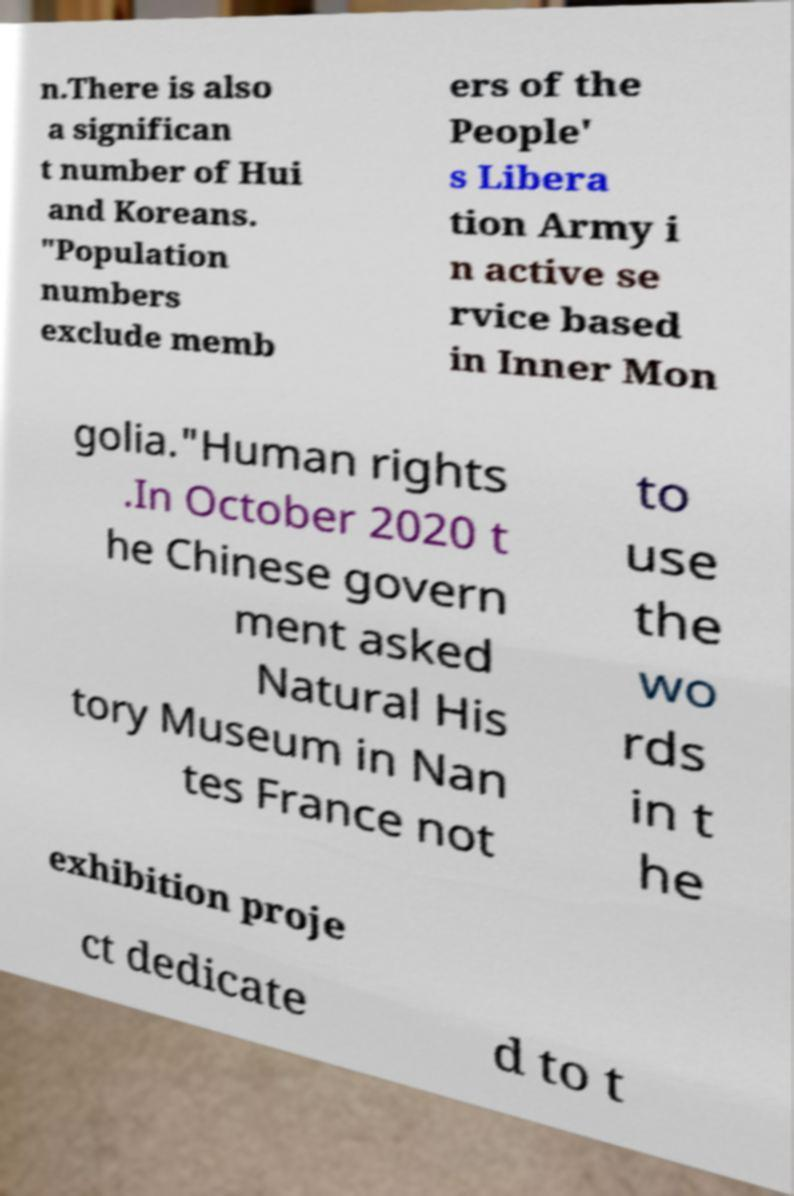Please identify and transcribe the text found in this image. n.There is also a significan t number of Hui and Koreans. "Population numbers exclude memb ers of the People' s Libera tion Army i n active se rvice based in Inner Mon golia."Human rights .In October 2020 t he Chinese govern ment asked Natural His tory Museum in Nan tes France not to use the wo rds in t he exhibition proje ct dedicate d to t 